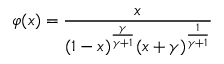Convert formula to latex. <formula><loc_0><loc_0><loc_500><loc_500>\varphi ( x ) = \frac { x } { ( 1 - x ) ^ { \frac { \gamma } { \gamma + 1 } } ( x + \gamma ) ^ { \frac { 1 } { \gamma + 1 } } }</formula> 